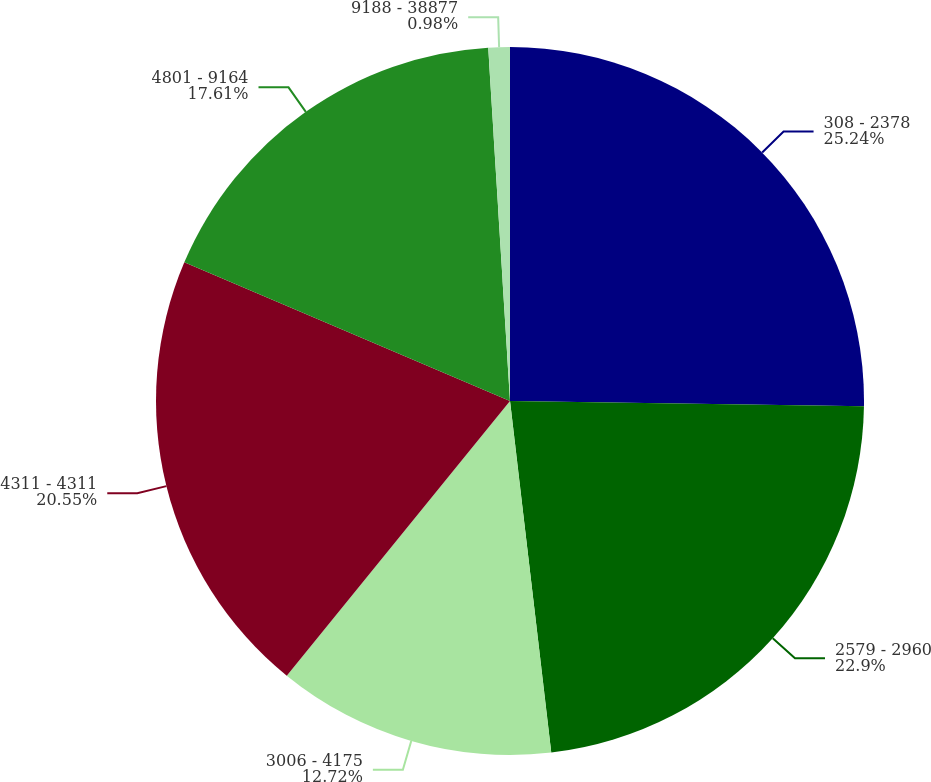<chart> <loc_0><loc_0><loc_500><loc_500><pie_chart><fcel>308 - 2378<fcel>2579 - 2960<fcel>3006 - 4175<fcel>4311 - 4311<fcel>4801 - 9164<fcel>9188 - 38877<nl><fcel>25.24%<fcel>22.9%<fcel>12.72%<fcel>20.55%<fcel>17.61%<fcel>0.98%<nl></chart> 